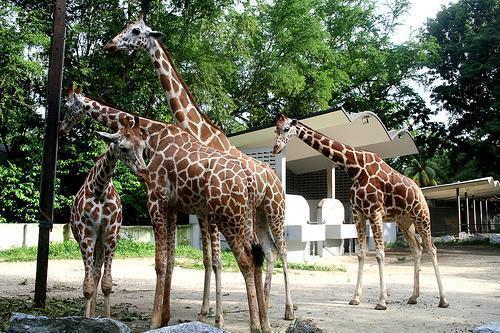How many giraffe are there?
Give a very brief answer. 4. 